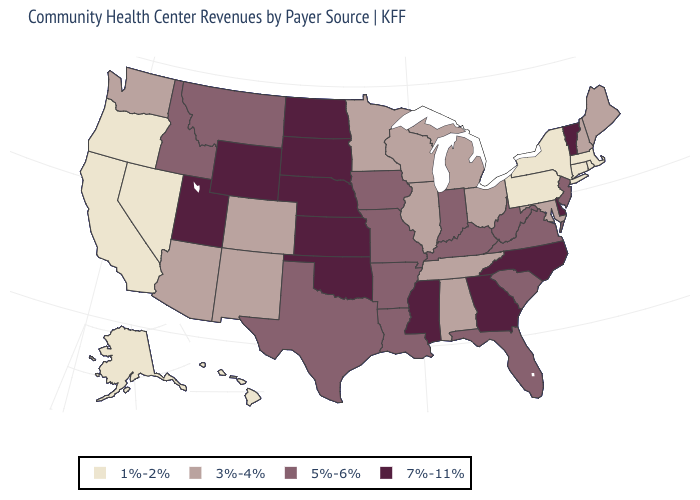What is the highest value in the Northeast ?
Answer briefly. 7%-11%. Which states hav the highest value in the MidWest?
Write a very short answer. Kansas, Nebraska, North Dakota, South Dakota. Does Kansas have the highest value in the USA?
Quick response, please. Yes. Name the states that have a value in the range 5%-6%?
Keep it brief. Arkansas, Florida, Idaho, Indiana, Iowa, Kentucky, Louisiana, Missouri, Montana, New Jersey, South Carolina, Texas, Virginia, West Virginia. Does Idaho have the same value as Virginia?
Write a very short answer. Yes. What is the highest value in states that border Texas?
Concise answer only. 7%-11%. What is the value of California?
Short answer required. 1%-2%. Does the first symbol in the legend represent the smallest category?
Short answer required. Yes. Among the states that border Alabama , does Tennessee have the highest value?
Keep it brief. No. Name the states that have a value in the range 3%-4%?
Quick response, please. Alabama, Arizona, Colorado, Illinois, Maine, Maryland, Michigan, Minnesota, New Hampshire, New Mexico, Ohio, Tennessee, Washington, Wisconsin. What is the value of Arkansas?
Short answer required. 5%-6%. What is the highest value in states that border Wyoming?
Keep it brief. 7%-11%. What is the value of North Carolina?
Concise answer only. 7%-11%. Among the states that border Virginia , which have the highest value?
Be succinct. North Carolina. Does Alaska have a higher value than Connecticut?
Keep it brief. No. 